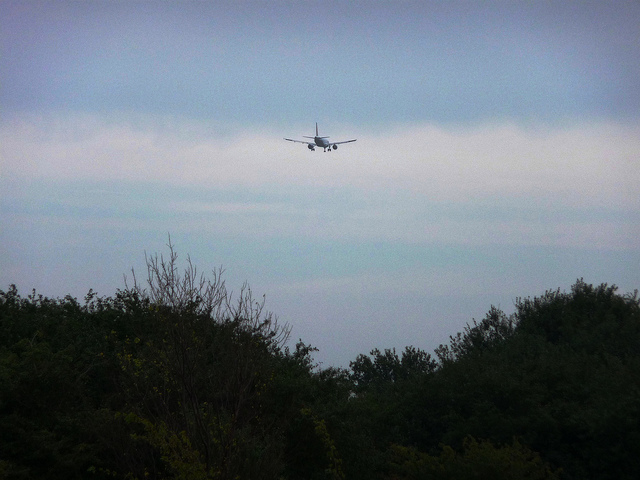<image>If the plane is flying east, will it see the sun rise? It depends on the time and location of the plane. If it's morning, then yes, the plane will see the sun rise. If it's not, then no. If the plane is flying east, will it see the sun rise? I am not sure if the plane will see the sun rise. It can be both yes or no. 